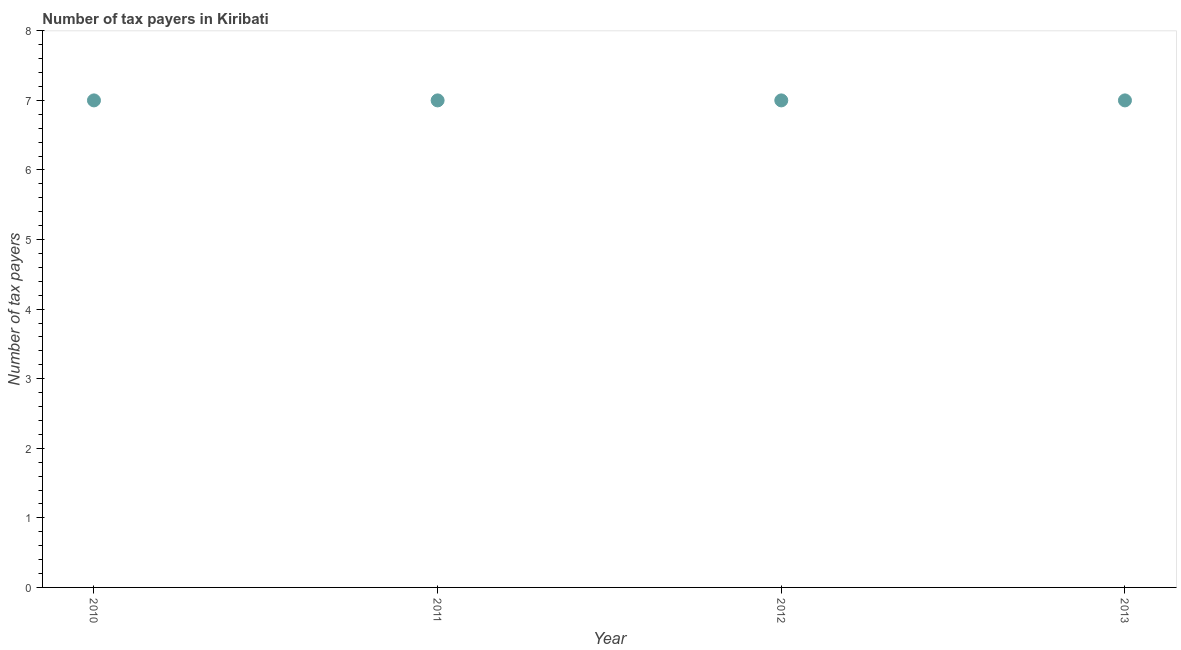What is the number of tax payers in 2011?
Your answer should be compact. 7. Across all years, what is the maximum number of tax payers?
Your response must be concise. 7. Across all years, what is the minimum number of tax payers?
Provide a short and direct response. 7. What is the sum of the number of tax payers?
Offer a very short reply. 28. What is the average number of tax payers per year?
Provide a short and direct response. 7. In how many years, is the number of tax payers greater than 0.6000000000000001 ?
Provide a short and direct response. 4. What is the ratio of the number of tax payers in 2010 to that in 2011?
Your answer should be very brief. 1. Is the sum of the number of tax payers in 2012 and 2013 greater than the maximum number of tax payers across all years?
Make the answer very short. Yes. In how many years, is the number of tax payers greater than the average number of tax payers taken over all years?
Your answer should be compact. 0. Does the number of tax payers monotonically increase over the years?
Keep it short and to the point. No. How many dotlines are there?
Your answer should be very brief. 1. Are the values on the major ticks of Y-axis written in scientific E-notation?
Give a very brief answer. No. Does the graph contain any zero values?
Provide a succinct answer. No. Does the graph contain grids?
Offer a terse response. No. What is the title of the graph?
Your answer should be compact. Number of tax payers in Kiribati. What is the label or title of the Y-axis?
Ensure brevity in your answer.  Number of tax payers. What is the Number of tax payers in 2012?
Offer a very short reply. 7. What is the Number of tax payers in 2013?
Give a very brief answer. 7. What is the difference between the Number of tax payers in 2010 and 2012?
Give a very brief answer. 0. What is the difference between the Number of tax payers in 2010 and 2013?
Your response must be concise. 0. What is the difference between the Number of tax payers in 2011 and 2012?
Offer a terse response. 0. What is the difference between the Number of tax payers in 2011 and 2013?
Provide a short and direct response. 0. What is the ratio of the Number of tax payers in 2010 to that in 2011?
Your answer should be very brief. 1. What is the ratio of the Number of tax payers in 2010 to that in 2013?
Provide a succinct answer. 1. What is the ratio of the Number of tax payers in 2011 to that in 2012?
Give a very brief answer. 1. What is the ratio of the Number of tax payers in 2011 to that in 2013?
Your answer should be very brief. 1. 